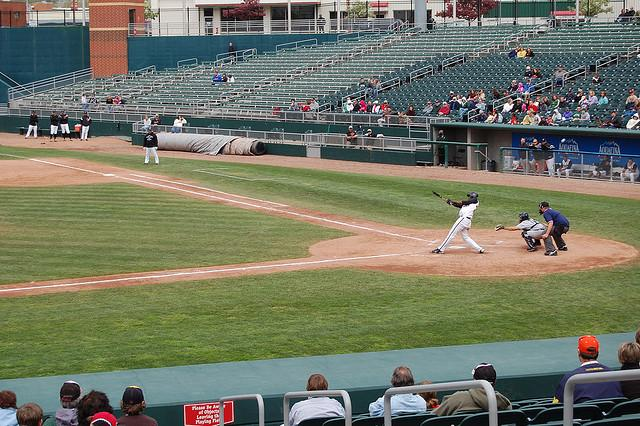How many players in baseball team? Please explain your reasoning. nine. Although more people can be on the team, there is a maximum number of positions that a team can field at one time, p, c, 1b, 2b, 3b, ss, rf, cf, lf. 